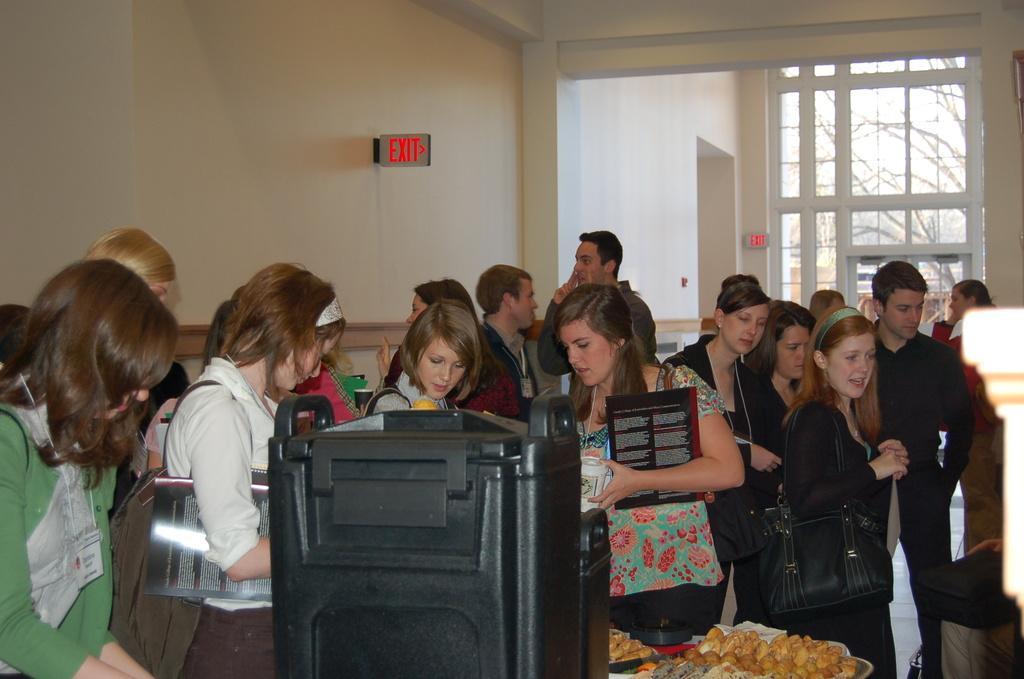How would you summarize this image in a sentence or two? In the middle of the image there is a black box. Behind the box there are food items. There are few people standing. They are wearing bags and holding books in their hands. Behind them there is a wall with sign boards and also there is a glass wall with doors. 